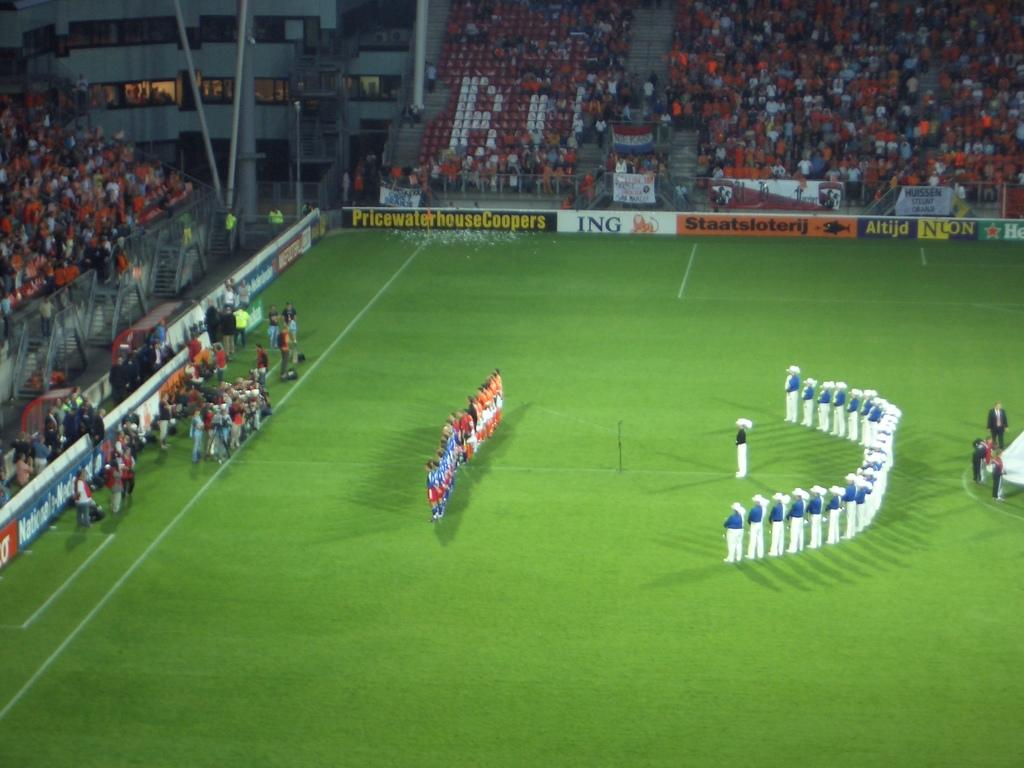Provide a one-sentence caption for the provided image. A group of people stand on the field of a stadium of which ING is one of the sponsors. 